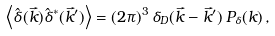<formula> <loc_0><loc_0><loc_500><loc_500>\left \langle \hat { \delta } ( \vec { k } ) \hat { \delta } ^ { * } ( \vec { k } ^ { \prime } ) \right \rangle = ( 2 \pi ) ^ { 3 } \, \delta _ { D } ( \vec { k } - \vec { k } ^ { \prime } ) \, P _ { \delta } ( k ) \, ,</formula> 